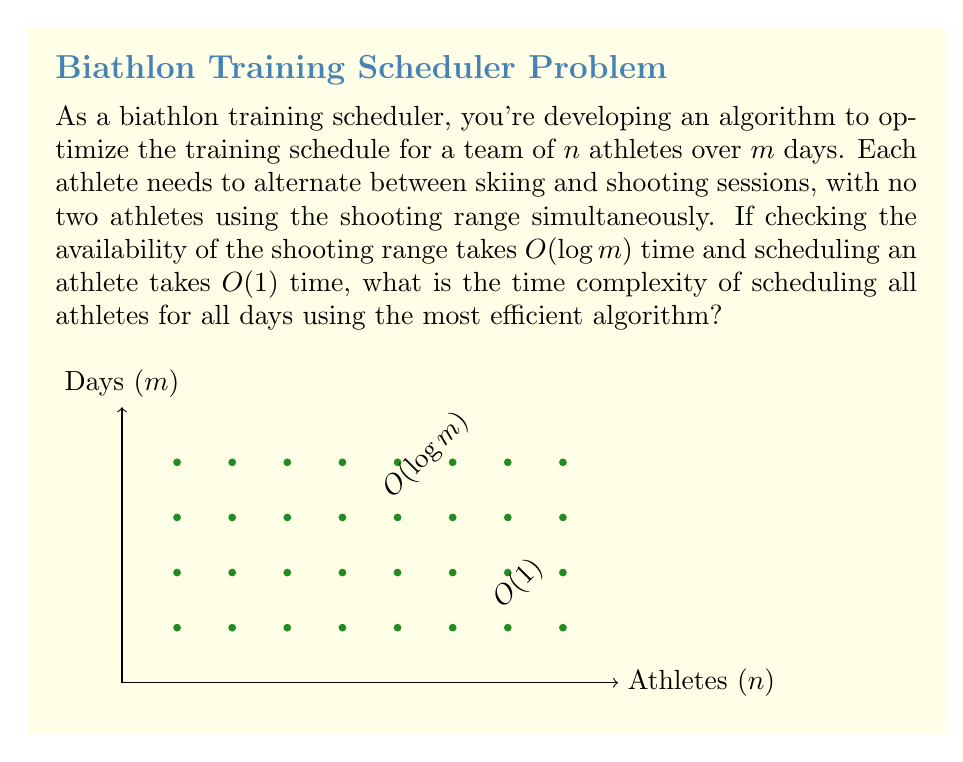Help me with this question. Let's approach this step-by-step:

1) We need to schedule each athlete for each day, so we'll have $n \times m$ total scheduling operations.

2) For each scheduling operation:
   a) We need to check the availability of the shooting range: $O(\log m)$
   b) We need to schedule the athlete: $O(1)$

3) The total time for one scheduling operation is thus $O(\log m + 1) = O(\log m)$

4) Since we perform this operation $n \times m$ times, the total time complexity is:

   $$O(n \times m \times \log m)$$

5) This can be simplified to:

   $$O(nm \log m)$$

6) This is the most efficient algorithm because:
   - We must consider each athlete on each day at least once (hence the $nm$ factor)
   - For each consideration, we must check the shooting range availability, which has a lower bound of $\Omega(\log m)$ for $m$ time slots

Therefore, $O(nm \log m)$ is the optimal time complexity for this scheduling problem.
Answer: $O(nm \log m)$ 